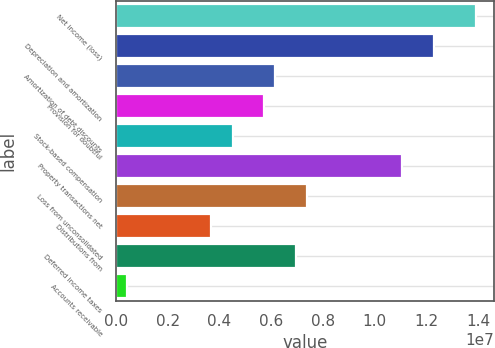Convert chart. <chart><loc_0><loc_0><loc_500><loc_500><bar_chart><fcel>Net income (loss)<fcel>Depreciation and amortization<fcel>Amortization of debt discounts<fcel>Provision for doubtful<fcel>Stock-based compensation<fcel>Property transactions net<fcel>Loss from unconsolidated<fcel>Distributions from<fcel>Deferred income taxes<fcel>Accounts receivable<nl><fcel>1.3939e+07<fcel>1.22991e+07<fcel>6.14979e+06<fcel>5.73983e+06<fcel>4.50996e+06<fcel>1.10693e+07<fcel>7.37966e+06<fcel>3.69004e+06<fcel>6.9697e+06<fcel>410383<nl></chart> 